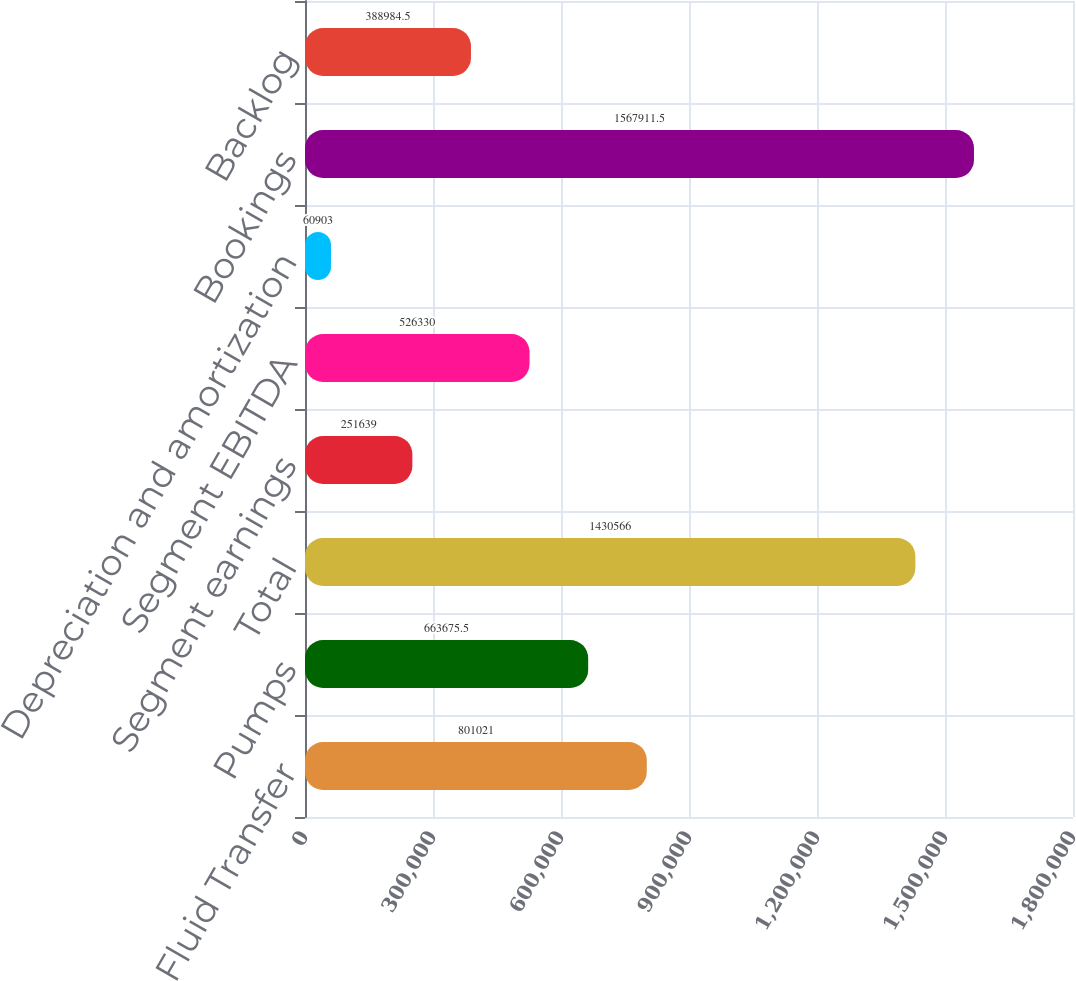Convert chart to OTSL. <chart><loc_0><loc_0><loc_500><loc_500><bar_chart><fcel>Fluid Transfer<fcel>Pumps<fcel>Total<fcel>Segment earnings<fcel>Segment EBITDA<fcel>Depreciation and amortization<fcel>Bookings<fcel>Backlog<nl><fcel>801021<fcel>663676<fcel>1.43057e+06<fcel>251639<fcel>526330<fcel>60903<fcel>1.56791e+06<fcel>388984<nl></chart> 